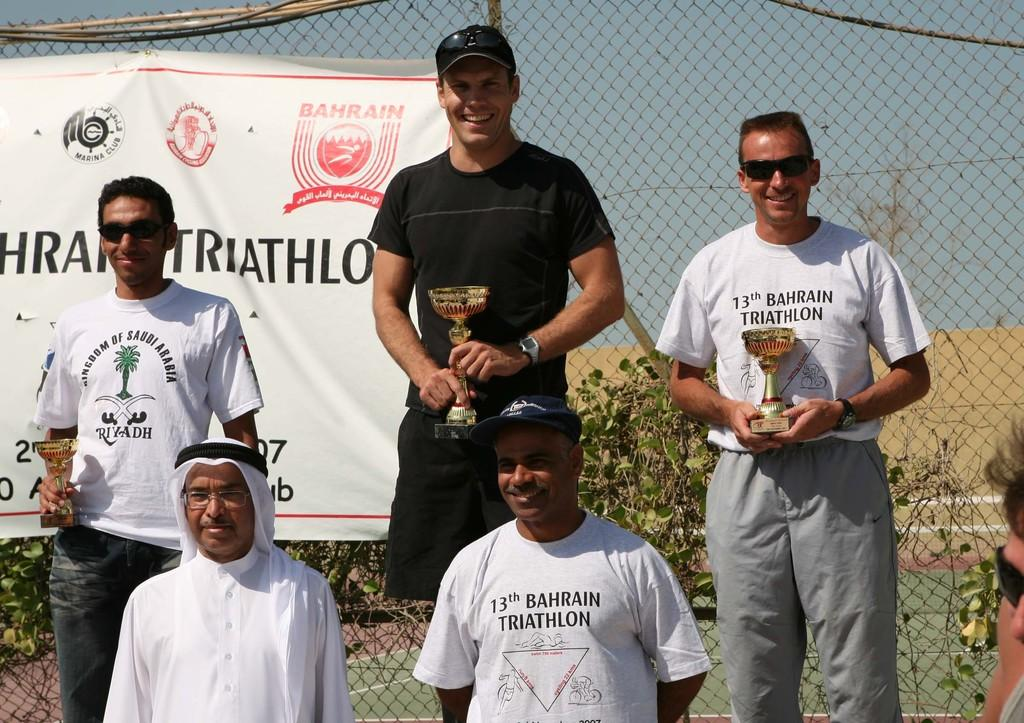<image>
Summarize the visual content of the image. several men wearing a white shirt that says '13th bahrain triathlon' 